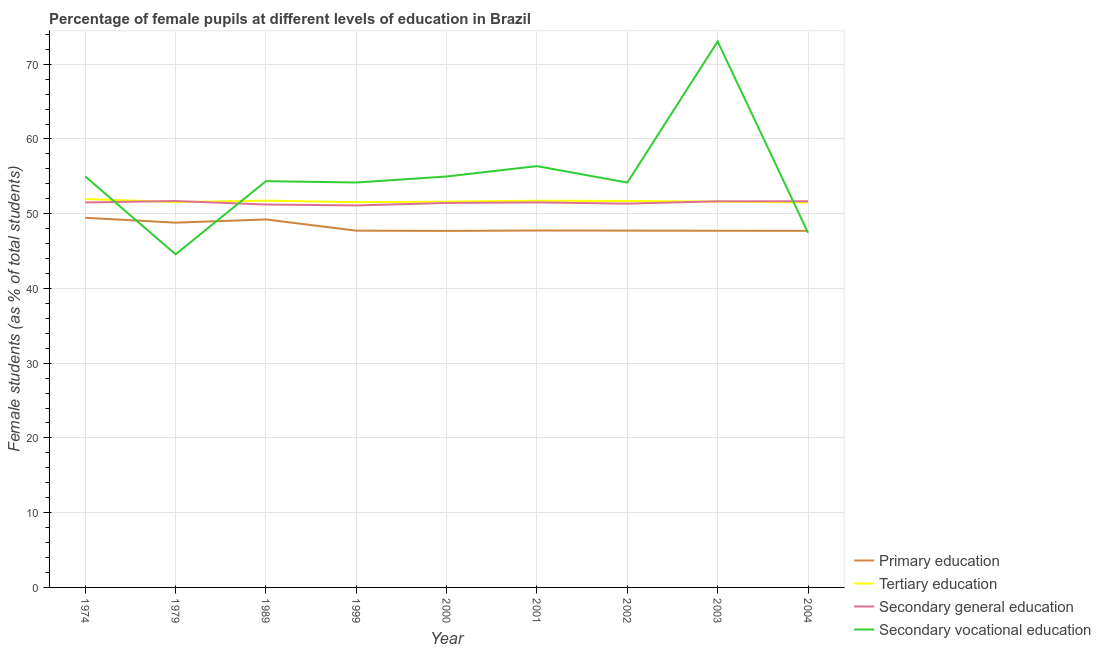How many different coloured lines are there?
Ensure brevity in your answer.  4. Does the line corresponding to percentage of female students in secondary education intersect with the line corresponding to percentage of female students in tertiary education?
Offer a terse response. Yes. What is the percentage of female students in secondary vocational education in 2001?
Provide a short and direct response. 56.37. Across all years, what is the maximum percentage of female students in secondary vocational education?
Keep it short and to the point. 73.04. Across all years, what is the minimum percentage of female students in secondary education?
Offer a terse response. 51.11. In which year was the percentage of female students in tertiary education maximum?
Offer a terse response. 1974. In which year was the percentage of female students in secondary vocational education minimum?
Keep it short and to the point. 1979. What is the total percentage of female students in secondary vocational education in the graph?
Offer a terse response. 494.09. What is the difference between the percentage of female students in secondary education in 1999 and that in 2001?
Your response must be concise. -0.4. What is the difference between the percentage of female students in secondary education in 2000 and the percentage of female students in primary education in 2003?
Ensure brevity in your answer.  3.72. What is the average percentage of female students in secondary vocational education per year?
Give a very brief answer. 54.9. In the year 1999, what is the difference between the percentage of female students in secondary education and percentage of female students in secondary vocational education?
Your response must be concise. -3.07. What is the ratio of the percentage of female students in tertiary education in 1979 to that in 2003?
Give a very brief answer. 1. What is the difference between the highest and the second highest percentage of female students in secondary education?
Keep it short and to the point. 0.03. What is the difference between the highest and the lowest percentage of female students in tertiary education?
Give a very brief answer. 0.47. In how many years, is the percentage of female students in secondary vocational education greater than the average percentage of female students in secondary vocational education taken over all years?
Offer a very short reply. 4. Is the sum of the percentage of female students in secondary vocational education in 1979 and 2001 greater than the maximum percentage of female students in primary education across all years?
Provide a succinct answer. Yes. Is it the case that in every year, the sum of the percentage of female students in secondary vocational education and percentage of female students in primary education is greater than the sum of percentage of female students in secondary education and percentage of female students in tertiary education?
Provide a short and direct response. No. Is the percentage of female students in secondary vocational education strictly greater than the percentage of female students in secondary education over the years?
Your answer should be compact. No. How many lines are there?
Offer a terse response. 4. Are the values on the major ticks of Y-axis written in scientific E-notation?
Offer a terse response. No. Does the graph contain any zero values?
Your answer should be very brief. No. Where does the legend appear in the graph?
Provide a succinct answer. Bottom right. How are the legend labels stacked?
Provide a short and direct response. Vertical. What is the title of the graph?
Provide a succinct answer. Percentage of female pupils at different levels of education in Brazil. Does "Third 20% of population" appear as one of the legend labels in the graph?
Your response must be concise. No. What is the label or title of the X-axis?
Offer a very short reply. Year. What is the label or title of the Y-axis?
Provide a short and direct response. Female students (as % of total students). What is the Female students (as % of total students) of Primary education in 1974?
Provide a succinct answer. 49.45. What is the Female students (as % of total students) in Tertiary education in 1974?
Keep it short and to the point. 51.97. What is the Female students (as % of total students) of Secondary general education in 1974?
Provide a succinct answer. 51.51. What is the Female students (as % of total students) in Secondary vocational education in 1974?
Keep it short and to the point. 54.98. What is the Female students (as % of total students) in Primary education in 1979?
Offer a very short reply. 48.8. What is the Female students (as % of total students) in Tertiary education in 1979?
Your response must be concise. 51.56. What is the Female students (as % of total students) in Secondary general education in 1979?
Provide a succinct answer. 51.7. What is the Female students (as % of total students) of Secondary vocational education in 1979?
Give a very brief answer. 44.57. What is the Female students (as % of total students) of Primary education in 1989?
Keep it short and to the point. 49.23. What is the Female students (as % of total students) of Tertiary education in 1989?
Give a very brief answer. 51.75. What is the Female students (as % of total students) of Secondary general education in 1989?
Give a very brief answer. 51.23. What is the Female students (as % of total students) of Secondary vocational education in 1989?
Offer a terse response. 54.36. What is the Female students (as % of total students) in Primary education in 1999?
Offer a very short reply. 47.73. What is the Female students (as % of total students) of Tertiary education in 1999?
Offer a very short reply. 51.54. What is the Female students (as % of total students) in Secondary general education in 1999?
Your response must be concise. 51.11. What is the Female students (as % of total students) in Secondary vocational education in 1999?
Give a very brief answer. 54.17. What is the Female students (as % of total students) of Primary education in 2000?
Provide a succinct answer. 47.7. What is the Female students (as % of total students) of Tertiary education in 2000?
Offer a terse response. 51.62. What is the Female students (as % of total students) in Secondary general education in 2000?
Offer a terse response. 51.44. What is the Female students (as % of total students) in Secondary vocational education in 2000?
Offer a very short reply. 54.98. What is the Female students (as % of total students) in Primary education in 2001?
Make the answer very short. 47.75. What is the Female students (as % of total students) in Tertiary education in 2001?
Your answer should be very brief. 51.74. What is the Female students (as % of total students) in Secondary general education in 2001?
Keep it short and to the point. 51.51. What is the Female students (as % of total students) in Secondary vocational education in 2001?
Provide a succinct answer. 56.37. What is the Female students (as % of total students) in Primary education in 2002?
Provide a short and direct response. 47.74. What is the Female students (as % of total students) in Tertiary education in 2002?
Your answer should be very brief. 51.71. What is the Female students (as % of total students) in Secondary general education in 2002?
Your response must be concise. 51.35. What is the Female students (as % of total students) in Secondary vocational education in 2002?
Your response must be concise. 54.16. What is the Female students (as % of total students) of Primary education in 2003?
Give a very brief answer. 47.72. What is the Female students (as % of total students) in Tertiary education in 2003?
Make the answer very short. 51.62. What is the Female students (as % of total students) in Secondary general education in 2003?
Your answer should be compact. 51.66. What is the Female students (as % of total students) of Secondary vocational education in 2003?
Provide a succinct answer. 73.04. What is the Female students (as % of total students) of Primary education in 2004?
Keep it short and to the point. 47.71. What is the Female students (as % of total students) of Tertiary education in 2004?
Give a very brief answer. 51.5. What is the Female students (as % of total students) in Secondary general education in 2004?
Ensure brevity in your answer.  51.66. What is the Female students (as % of total students) of Secondary vocational education in 2004?
Make the answer very short. 47.46. Across all years, what is the maximum Female students (as % of total students) of Primary education?
Provide a succinct answer. 49.45. Across all years, what is the maximum Female students (as % of total students) in Tertiary education?
Your answer should be compact. 51.97. Across all years, what is the maximum Female students (as % of total students) of Secondary general education?
Your response must be concise. 51.7. Across all years, what is the maximum Female students (as % of total students) in Secondary vocational education?
Provide a short and direct response. 73.04. Across all years, what is the minimum Female students (as % of total students) of Primary education?
Ensure brevity in your answer.  47.7. Across all years, what is the minimum Female students (as % of total students) in Tertiary education?
Offer a terse response. 51.5. Across all years, what is the minimum Female students (as % of total students) in Secondary general education?
Provide a succinct answer. 51.11. Across all years, what is the minimum Female students (as % of total students) in Secondary vocational education?
Keep it short and to the point. 44.57. What is the total Female students (as % of total students) of Primary education in the graph?
Ensure brevity in your answer.  433.83. What is the total Female students (as % of total students) in Tertiary education in the graph?
Offer a very short reply. 464.99. What is the total Female students (as % of total students) in Secondary general education in the graph?
Ensure brevity in your answer.  463.16. What is the total Female students (as % of total students) in Secondary vocational education in the graph?
Provide a succinct answer. 494.09. What is the difference between the Female students (as % of total students) in Primary education in 1974 and that in 1979?
Offer a terse response. 0.65. What is the difference between the Female students (as % of total students) of Tertiary education in 1974 and that in 1979?
Your response must be concise. 0.41. What is the difference between the Female students (as % of total students) of Secondary general education in 1974 and that in 1979?
Your response must be concise. -0.19. What is the difference between the Female students (as % of total students) of Secondary vocational education in 1974 and that in 1979?
Provide a succinct answer. 10.41. What is the difference between the Female students (as % of total students) in Primary education in 1974 and that in 1989?
Give a very brief answer. 0.22. What is the difference between the Female students (as % of total students) in Tertiary education in 1974 and that in 1989?
Provide a short and direct response. 0.22. What is the difference between the Female students (as % of total students) in Secondary general education in 1974 and that in 1989?
Your answer should be very brief. 0.28. What is the difference between the Female students (as % of total students) in Secondary vocational education in 1974 and that in 1989?
Give a very brief answer. 0.62. What is the difference between the Female students (as % of total students) in Primary education in 1974 and that in 1999?
Your answer should be compact. 1.72. What is the difference between the Female students (as % of total students) of Tertiary education in 1974 and that in 1999?
Offer a very short reply. 0.43. What is the difference between the Female students (as % of total students) in Secondary general education in 1974 and that in 1999?
Your response must be concise. 0.4. What is the difference between the Female students (as % of total students) in Secondary vocational education in 1974 and that in 1999?
Your answer should be very brief. 0.8. What is the difference between the Female students (as % of total students) of Primary education in 1974 and that in 2000?
Your answer should be compact. 1.75. What is the difference between the Female students (as % of total students) in Tertiary education in 1974 and that in 2000?
Make the answer very short. 0.34. What is the difference between the Female students (as % of total students) in Secondary general education in 1974 and that in 2000?
Ensure brevity in your answer.  0.07. What is the difference between the Female students (as % of total students) of Secondary vocational education in 1974 and that in 2000?
Your answer should be very brief. -0. What is the difference between the Female students (as % of total students) in Primary education in 1974 and that in 2001?
Provide a succinct answer. 1.7. What is the difference between the Female students (as % of total students) of Tertiary education in 1974 and that in 2001?
Ensure brevity in your answer.  0.23. What is the difference between the Female students (as % of total students) of Secondary general education in 1974 and that in 2001?
Offer a terse response. -0. What is the difference between the Female students (as % of total students) of Secondary vocational education in 1974 and that in 2001?
Ensure brevity in your answer.  -1.39. What is the difference between the Female students (as % of total students) of Primary education in 1974 and that in 2002?
Provide a succinct answer. 1.71. What is the difference between the Female students (as % of total students) of Tertiary education in 1974 and that in 2002?
Ensure brevity in your answer.  0.26. What is the difference between the Female students (as % of total students) in Secondary general education in 1974 and that in 2002?
Provide a succinct answer. 0.16. What is the difference between the Female students (as % of total students) in Secondary vocational education in 1974 and that in 2002?
Provide a succinct answer. 0.81. What is the difference between the Female students (as % of total students) in Primary education in 1974 and that in 2003?
Your response must be concise. 1.73. What is the difference between the Female students (as % of total students) of Tertiary education in 1974 and that in 2003?
Offer a terse response. 0.35. What is the difference between the Female students (as % of total students) of Secondary general education in 1974 and that in 2003?
Your answer should be very brief. -0.15. What is the difference between the Female students (as % of total students) in Secondary vocational education in 1974 and that in 2003?
Provide a succinct answer. -18.07. What is the difference between the Female students (as % of total students) of Primary education in 1974 and that in 2004?
Offer a very short reply. 1.75. What is the difference between the Female students (as % of total students) in Tertiary education in 1974 and that in 2004?
Your response must be concise. 0.47. What is the difference between the Female students (as % of total students) in Secondary general education in 1974 and that in 2004?
Make the answer very short. -0.15. What is the difference between the Female students (as % of total students) of Secondary vocational education in 1974 and that in 2004?
Make the answer very short. 7.52. What is the difference between the Female students (as % of total students) in Primary education in 1979 and that in 1989?
Give a very brief answer. -0.43. What is the difference between the Female students (as % of total students) in Tertiary education in 1979 and that in 1989?
Offer a terse response. -0.19. What is the difference between the Female students (as % of total students) in Secondary general education in 1979 and that in 1989?
Your response must be concise. 0.47. What is the difference between the Female students (as % of total students) of Secondary vocational education in 1979 and that in 1989?
Provide a short and direct response. -9.79. What is the difference between the Female students (as % of total students) of Primary education in 1979 and that in 1999?
Provide a succinct answer. 1.07. What is the difference between the Female students (as % of total students) of Tertiary education in 1979 and that in 1999?
Offer a very short reply. 0.02. What is the difference between the Female students (as % of total students) in Secondary general education in 1979 and that in 1999?
Provide a short and direct response. 0.59. What is the difference between the Female students (as % of total students) of Secondary vocational education in 1979 and that in 1999?
Your answer should be very brief. -9.61. What is the difference between the Female students (as % of total students) in Primary education in 1979 and that in 2000?
Offer a terse response. 1.1. What is the difference between the Female students (as % of total students) in Tertiary education in 1979 and that in 2000?
Provide a succinct answer. -0.06. What is the difference between the Female students (as % of total students) of Secondary general education in 1979 and that in 2000?
Offer a very short reply. 0.26. What is the difference between the Female students (as % of total students) in Secondary vocational education in 1979 and that in 2000?
Your response must be concise. -10.41. What is the difference between the Female students (as % of total students) in Primary education in 1979 and that in 2001?
Your answer should be compact. 1.05. What is the difference between the Female students (as % of total students) in Tertiary education in 1979 and that in 2001?
Offer a very short reply. -0.18. What is the difference between the Female students (as % of total students) of Secondary general education in 1979 and that in 2001?
Offer a terse response. 0.18. What is the difference between the Female students (as % of total students) in Secondary vocational education in 1979 and that in 2001?
Your response must be concise. -11.8. What is the difference between the Female students (as % of total students) in Primary education in 1979 and that in 2002?
Provide a short and direct response. 1.06. What is the difference between the Female students (as % of total students) of Tertiary education in 1979 and that in 2002?
Your response must be concise. -0.15. What is the difference between the Female students (as % of total students) in Secondary general education in 1979 and that in 2002?
Your answer should be compact. 0.35. What is the difference between the Female students (as % of total students) of Secondary vocational education in 1979 and that in 2002?
Your answer should be very brief. -9.6. What is the difference between the Female students (as % of total students) in Primary education in 1979 and that in 2003?
Give a very brief answer. 1.08. What is the difference between the Female students (as % of total students) in Tertiary education in 1979 and that in 2003?
Make the answer very short. -0.06. What is the difference between the Female students (as % of total students) in Secondary general education in 1979 and that in 2003?
Give a very brief answer. 0.04. What is the difference between the Female students (as % of total students) of Secondary vocational education in 1979 and that in 2003?
Give a very brief answer. -28.48. What is the difference between the Female students (as % of total students) in Primary education in 1979 and that in 2004?
Keep it short and to the point. 1.1. What is the difference between the Female students (as % of total students) in Tertiary education in 1979 and that in 2004?
Your answer should be compact. 0.06. What is the difference between the Female students (as % of total students) in Secondary general education in 1979 and that in 2004?
Provide a short and direct response. 0.03. What is the difference between the Female students (as % of total students) in Secondary vocational education in 1979 and that in 2004?
Provide a short and direct response. -2.89. What is the difference between the Female students (as % of total students) in Primary education in 1989 and that in 1999?
Offer a very short reply. 1.5. What is the difference between the Female students (as % of total students) of Tertiary education in 1989 and that in 1999?
Give a very brief answer. 0.21. What is the difference between the Female students (as % of total students) in Secondary general education in 1989 and that in 1999?
Keep it short and to the point. 0.12. What is the difference between the Female students (as % of total students) in Secondary vocational education in 1989 and that in 1999?
Keep it short and to the point. 0.19. What is the difference between the Female students (as % of total students) of Primary education in 1989 and that in 2000?
Provide a short and direct response. 1.53. What is the difference between the Female students (as % of total students) in Tertiary education in 1989 and that in 2000?
Your answer should be compact. 0.12. What is the difference between the Female students (as % of total students) in Secondary general education in 1989 and that in 2000?
Your response must be concise. -0.21. What is the difference between the Female students (as % of total students) of Secondary vocational education in 1989 and that in 2000?
Ensure brevity in your answer.  -0.62. What is the difference between the Female students (as % of total students) in Primary education in 1989 and that in 2001?
Your answer should be compact. 1.48. What is the difference between the Female students (as % of total students) in Tertiary education in 1989 and that in 2001?
Provide a short and direct response. 0.01. What is the difference between the Female students (as % of total students) in Secondary general education in 1989 and that in 2001?
Provide a succinct answer. -0.28. What is the difference between the Female students (as % of total students) in Secondary vocational education in 1989 and that in 2001?
Make the answer very short. -2.01. What is the difference between the Female students (as % of total students) in Primary education in 1989 and that in 2002?
Keep it short and to the point. 1.49. What is the difference between the Female students (as % of total students) in Tertiary education in 1989 and that in 2002?
Give a very brief answer. 0.04. What is the difference between the Female students (as % of total students) in Secondary general education in 1989 and that in 2002?
Make the answer very short. -0.12. What is the difference between the Female students (as % of total students) of Secondary vocational education in 1989 and that in 2002?
Make the answer very short. 0.19. What is the difference between the Female students (as % of total students) in Primary education in 1989 and that in 2003?
Ensure brevity in your answer.  1.51. What is the difference between the Female students (as % of total students) in Tertiary education in 1989 and that in 2003?
Provide a succinct answer. 0.13. What is the difference between the Female students (as % of total students) of Secondary general education in 1989 and that in 2003?
Your answer should be very brief. -0.43. What is the difference between the Female students (as % of total students) of Secondary vocational education in 1989 and that in 2003?
Provide a short and direct response. -18.69. What is the difference between the Female students (as % of total students) of Primary education in 1989 and that in 2004?
Provide a short and direct response. 1.52. What is the difference between the Female students (as % of total students) of Tertiary education in 1989 and that in 2004?
Your answer should be very brief. 0.25. What is the difference between the Female students (as % of total students) of Secondary general education in 1989 and that in 2004?
Provide a succinct answer. -0.43. What is the difference between the Female students (as % of total students) in Secondary vocational education in 1989 and that in 2004?
Provide a succinct answer. 6.9. What is the difference between the Female students (as % of total students) of Primary education in 1999 and that in 2000?
Provide a short and direct response. 0.03. What is the difference between the Female students (as % of total students) of Tertiary education in 1999 and that in 2000?
Offer a very short reply. -0.09. What is the difference between the Female students (as % of total students) of Secondary general education in 1999 and that in 2000?
Provide a succinct answer. -0.33. What is the difference between the Female students (as % of total students) in Secondary vocational education in 1999 and that in 2000?
Make the answer very short. -0.81. What is the difference between the Female students (as % of total students) in Primary education in 1999 and that in 2001?
Offer a very short reply. -0.02. What is the difference between the Female students (as % of total students) in Tertiary education in 1999 and that in 2001?
Give a very brief answer. -0.2. What is the difference between the Female students (as % of total students) in Secondary general education in 1999 and that in 2001?
Make the answer very short. -0.4. What is the difference between the Female students (as % of total students) in Secondary vocational education in 1999 and that in 2001?
Give a very brief answer. -2.2. What is the difference between the Female students (as % of total students) of Primary education in 1999 and that in 2002?
Make the answer very short. -0.01. What is the difference between the Female students (as % of total students) in Tertiary education in 1999 and that in 2002?
Give a very brief answer. -0.17. What is the difference between the Female students (as % of total students) of Secondary general education in 1999 and that in 2002?
Give a very brief answer. -0.24. What is the difference between the Female students (as % of total students) of Secondary vocational education in 1999 and that in 2002?
Provide a short and direct response. 0.01. What is the difference between the Female students (as % of total students) of Primary education in 1999 and that in 2003?
Your answer should be very brief. 0.01. What is the difference between the Female students (as % of total students) in Tertiary education in 1999 and that in 2003?
Provide a succinct answer. -0.08. What is the difference between the Female students (as % of total students) in Secondary general education in 1999 and that in 2003?
Offer a terse response. -0.55. What is the difference between the Female students (as % of total students) in Secondary vocational education in 1999 and that in 2003?
Ensure brevity in your answer.  -18.87. What is the difference between the Female students (as % of total students) of Primary education in 1999 and that in 2004?
Ensure brevity in your answer.  0.02. What is the difference between the Female students (as % of total students) of Tertiary education in 1999 and that in 2004?
Ensure brevity in your answer.  0.04. What is the difference between the Female students (as % of total students) in Secondary general education in 1999 and that in 2004?
Make the answer very short. -0.56. What is the difference between the Female students (as % of total students) in Secondary vocational education in 1999 and that in 2004?
Give a very brief answer. 6.71. What is the difference between the Female students (as % of total students) of Primary education in 2000 and that in 2001?
Give a very brief answer. -0.05. What is the difference between the Female students (as % of total students) of Tertiary education in 2000 and that in 2001?
Provide a succinct answer. -0.11. What is the difference between the Female students (as % of total students) of Secondary general education in 2000 and that in 2001?
Keep it short and to the point. -0.07. What is the difference between the Female students (as % of total students) of Secondary vocational education in 2000 and that in 2001?
Your answer should be compact. -1.39. What is the difference between the Female students (as % of total students) of Primary education in 2000 and that in 2002?
Give a very brief answer. -0.04. What is the difference between the Female students (as % of total students) in Tertiary education in 2000 and that in 2002?
Your answer should be very brief. -0.08. What is the difference between the Female students (as % of total students) in Secondary general education in 2000 and that in 2002?
Offer a very short reply. 0.09. What is the difference between the Female students (as % of total students) in Secondary vocational education in 2000 and that in 2002?
Your answer should be compact. 0.82. What is the difference between the Female students (as % of total students) in Primary education in 2000 and that in 2003?
Provide a short and direct response. -0.02. What is the difference between the Female students (as % of total students) of Tertiary education in 2000 and that in 2003?
Offer a terse response. 0. What is the difference between the Female students (as % of total students) in Secondary general education in 2000 and that in 2003?
Make the answer very short. -0.22. What is the difference between the Female students (as % of total students) in Secondary vocational education in 2000 and that in 2003?
Ensure brevity in your answer.  -18.07. What is the difference between the Female students (as % of total students) in Primary education in 2000 and that in 2004?
Keep it short and to the point. -0.01. What is the difference between the Female students (as % of total students) of Tertiary education in 2000 and that in 2004?
Give a very brief answer. 0.12. What is the difference between the Female students (as % of total students) in Secondary general education in 2000 and that in 2004?
Make the answer very short. -0.22. What is the difference between the Female students (as % of total students) of Secondary vocational education in 2000 and that in 2004?
Provide a succinct answer. 7.52. What is the difference between the Female students (as % of total students) of Primary education in 2001 and that in 2002?
Offer a very short reply. 0.02. What is the difference between the Female students (as % of total students) of Tertiary education in 2001 and that in 2002?
Offer a very short reply. 0.03. What is the difference between the Female students (as % of total students) in Secondary general education in 2001 and that in 2002?
Provide a succinct answer. 0.16. What is the difference between the Female students (as % of total students) of Secondary vocational education in 2001 and that in 2002?
Offer a very short reply. 2.2. What is the difference between the Female students (as % of total students) of Primary education in 2001 and that in 2003?
Your answer should be very brief. 0.03. What is the difference between the Female students (as % of total students) in Tertiary education in 2001 and that in 2003?
Your response must be concise. 0.12. What is the difference between the Female students (as % of total students) of Secondary general education in 2001 and that in 2003?
Provide a succinct answer. -0.15. What is the difference between the Female students (as % of total students) of Secondary vocational education in 2001 and that in 2003?
Provide a short and direct response. -16.68. What is the difference between the Female students (as % of total students) of Primary education in 2001 and that in 2004?
Your response must be concise. 0.05. What is the difference between the Female students (as % of total students) in Tertiary education in 2001 and that in 2004?
Give a very brief answer. 0.24. What is the difference between the Female students (as % of total students) in Secondary general education in 2001 and that in 2004?
Offer a very short reply. -0.15. What is the difference between the Female students (as % of total students) of Secondary vocational education in 2001 and that in 2004?
Your response must be concise. 8.91. What is the difference between the Female students (as % of total students) of Primary education in 2002 and that in 2003?
Make the answer very short. 0.02. What is the difference between the Female students (as % of total students) in Tertiary education in 2002 and that in 2003?
Make the answer very short. 0.09. What is the difference between the Female students (as % of total students) in Secondary general education in 2002 and that in 2003?
Your response must be concise. -0.31. What is the difference between the Female students (as % of total students) of Secondary vocational education in 2002 and that in 2003?
Ensure brevity in your answer.  -18.88. What is the difference between the Female students (as % of total students) in Primary education in 2002 and that in 2004?
Ensure brevity in your answer.  0.03. What is the difference between the Female students (as % of total students) of Tertiary education in 2002 and that in 2004?
Your answer should be compact. 0.21. What is the difference between the Female students (as % of total students) in Secondary general education in 2002 and that in 2004?
Provide a succinct answer. -0.32. What is the difference between the Female students (as % of total students) of Secondary vocational education in 2002 and that in 2004?
Make the answer very short. 6.7. What is the difference between the Female students (as % of total students) of Primary education in 2003 and that in 2004?
Your answer should be very brief. 0.01. What is the difference between the Female students (as % of total students) in Tertiary education in 2003 and that in 2004?
Provide a succinct answer. 0.12. What is the difference between the Female students (as % of total students) in Secondary general education in 2003 and that in 2004?
Offer a very short reply. -0.01. What is the difference between the Female students (as % of total students) of Secondary vocational education in 2003 and that in 2004?
Keep it short and to the point. 25.58. What is the difference between the Female students (as % of total students) in Primary education in 1974 and the Female students (as % of total students) in Tertiary education in 1979?
Provide a short and direct response. -2.11. What is the difference between the Female students (as % of total students) of Primary education in 1974 and the Female students (as % of total students) of Secondary general education in 1979?
Ensure brevity in your answer.  -2.24. What is the difference between the Female students (as % of total students) in Primary education in 1974 and the Female students (as % of total students) in Secondary vocational education in 1979?
Offer a terse response. 4.88. What is the difference between the Female students (as % of total students) of Tertiary education in 1974 and the Female students (as % of total students) of Secondary general education in 1979?
Your response must be concise. 0.27. What is the difference between the Female students (as % of total students) in Tertiary education in 1974 and the Female students (as % of total students) in Secondary vocational education in 1979?
Offer a very short reply. 7.4. What is the difference between the Female students (as % of total students) in Secondary general education in 1974 and the Female students (as % of total students) in Secondary vocational education in 1979?
Provide a succinct answer. 6.94. What is the difference between the Female students (as % of total students) in Primary education in 1974 and the Female students (as % of total students) in Tertiary education in 1989?
Provide a succinct answer. -2.3. What is the difference between the Female students (as % of total students) in Primary education in 1974 and the Female students (as % of total students) in Secondary general education in 1989?
Ensure brevity in your answer.  -1.78. What is the difference between the Female students (as % of total students) of Primary education in 1974 and the Female students (as % of total students) of Secondary vocational education in 1989?
Your answer should be very brief. -4.91. What is the difference between the Female students (as % of total students) of Tertiary education in 1974 and the Female students (as % of total students) of Secondary general education in 1989?
Offer a terse response. 0.73. What is the difference between the Female students (as % of total students) in Tertiary education in 1974 and the Female students (as % of total students) in Secondary vocational education in 1989?
Ensure brevity in your answer.  -2.39. What is the difference between the Female students (as % of total students) of Secondary general education in 1974 and the Female students (as % of total students) of Secondary vocational education in 1989?
Your answer should be very brief. -2.85. What is the difference between the Female students (as % of total students) in Primary education in 1974 and the Female students (as % of total students) in Tertiary education in 1999?
Your answer should be compact. -2.09. What is the difference between the Female students (as % of total students) in Primary education in 1974 and the Female students (as % of total students) in Secondary general education in 1999?
Give a very brief answer. -1.66. What is the difference between the Female students (as % of total students) in Primary education in 1974 and the Female students (as % of total students) in Secondary vocational education in 1999?
Ensure brevity in your answer.  -4.72. What is the difference between the Female students (as % of total students) in Tertiary education in 1974 and the Female students (as % of total students) in Secondary general education in 1999?
Provide a short and direct response. 0.86. What is the difference between the Female students (as % of total students) in Tertiary education in 1974 and the Female students (as % of total students) in Secondary vocational education in 1999?
Offer a terse response. -2.21. What is the difference between the Female students (as % of total students) in Secondary general education in 1974 and the Female students (as % of total students) in Secondary vocational education in 1999?
Make the answer very short. -2.66. What is the difference between the Female students (as % of total students) in Primary education in 1974 and the Female students (as % of total students) in Tertiary education in 2000?
Ensure brevity in your answer.  -2.17. What is the difference between the Female students (as % of total students) in Primary education in 1974 and the Female students (as % of total students) in Secondary general education in 2000?
Ensure brevity in your answer.  -1.99. What is the difference between the Female students (as % of total students) of Primary education in 1974 and the Female students (as % of total students) of Secondary vocational education in 2000?
Your response must be concise. -5.53. What is the difference between the Female students (as % of total students) of Tertiary education in 1974 and the Female students (as % of total students) of Secondary general education in 2000?
Your answer should be very brief. 0.53. What is the difference between the Female students (as % of total students) in Tertiary education in 1974 and the Female students (as % of total students) in Secondary vocational education in 2000?
Make the answer very short. -3.01. What is the difference between the Female students (as % of total students) of Secondary general education in 1974 and the Female students (as % of total students) of Secondary vocational education in 2000?
Make the answer very short. -3.47. What is the difference between the Female students (as % of total students) in Primary education in 1974 and the Female students (as % of total students) in Tertiary education in 2001?
Your response must be concise. -2.28. What is the difference between the Female students (as % of total students) in Primary education in 1974 and the Female students (as % of total students) in Secondary general education in 2001?
Keep it short and to the point. -2.06. What is the difference between the Female students (as % of total students) of Primary education in 1974 and the Female students (as % of total students) of Secondary vocational education in 2001?
Your answer should be compact. -6.92. What is the difference between the Female students (as % of total students) of Tertiary education in 1974 and the Female students (as % of total students) of Secondary general education in 2001?
Your response must be concise. 0.45. What is the difference between the Female students (as % of total students) in Tertiary education in 1974 and the Female students (as % of total students) in Secondary vocational education in 2001?
Provide a succinct answer. -4.4. What is the difference between the Female students (as % of total students) of Secondary general education in 1974 and the Female students (as % of total students) of Secondary vocational education in 2001?
Provide a short and direct response. -4.86. What is the difference between the Female students (as % of total students) in Primary education in 1974 and the Female students (as % of total students) in Tertiary education in 2002?
Your answer should be compact. -2.25. What is the difference between the Female students (as % of total students) of Primary education in 1974 and the Female students (as % of total students) of Secondary general education in 2002?
Offer a very short reply. -1.9. What is the difference between the Female students (as % of total students) of Primary education in 1974 and the Female students (as % of total students) of Secondary vocational education in 2002?
Your answer should be very brief. -4.71. What is the difference between the Female students (as % of total students) of Tertiary education in 1974 and the Female students (as % of total students) of Secondary general education in 2002?
Keep it short and to the point. 0.62. What is the difference between the Female students (as % of total students) of Tertiary education in 1974 and the Female students (as % of total students) of Secondary vocational education in 2002?
Ensure brevity in your answer.  -2.2. What is the difference between the Female students (as % of total students) of Secondary general education in 1974 and the Female students (as % of total students) of Secondary vocational education in 2002?
Give a very brief answer. -2.65. What is the difference between the Female students (as % of total students) of Primary education in 1974 and the Female students (as % of total students) of Tertiary education in 2003?
Make the answer very short. -2.17. What is the difference between the Female students (as % of total students) of Primary education in 1974 and the Female students (as % of total students) of Secondary general education in 2003?
Your response must be concise. -2.21. What is the difference between the Female students (as % of total students) in Primary education in 1974 and the Female students (as % of total students) in Secondary vocational education in 2003?
Your answer should be compact. -23.59. What is the difference between the Female students (as % of total students) of Tertiary education in 1974 and the Female students (as % of total students) of Secondary general education in 2003?
Make the answer very short. 0.31. What is the difference between the Female students (as % of total students) of Tertiary education in 1974 and the Female students (as % of total students) of Secondary vocational education in 2003?
Your answer should be very brief. -21.08. What is the difference between the Female students (as % of total students) in Secondary general education in 1974 and the Female students (as % of total students) in Secondary vocational education in 2003?
Provide a succinct answer. -21.53. What is the difference between the Female students (as % of total students) in Primary education in 1974 and the Female students (as % of total students) in Tertiary education in 2004?
Your answer should be very brief. -2.05. What is the difference between the Female students (as % of total students) in Primary education in 1974 and the Female students (as % of total students) in Secondary general education in 2004?
Provide a succinct answer. -2.21. What is the difference between the Female students (as % of total students) of Primary education in 1974 and the Female students (as % of total students) of Secondary vocational education in 2004?
Offer a terse response. 1.99. What is the difference between the Female students (as % of total students) in Tertiary education in 1974 and the Female students (as % of total students) in Secondary general education in 2004?
Keep it short and to the point. 0.3. What is the difference between the Female students (as % of total students) in Tertiary education in 1974 and the Female students (as % of total students) in Secondary vocational education in 2004?
Make the answer very short. 4.5. What is the difference between the Female students (as % of total students) of Secondary general education in 1974 and the Female students (as % of total students) of Secondary vocational education in 2004?
Offer a very short reply. 4.05. What is the difference between the Female students (as % of total students) in Primary education in 1979 and the Female students (as % of total students) in Tertiary education in 1989?
Provide a short and direct response. -2.94. What is the difference between the Female students (as % of total students) in Primary education in 1979 and the Female students (as % of total students) in Secondary general education in 1989?
Your answer should be very brief. -2.43. What is the difference between the Female students (as % of total students) in Primary education in 1979 and the Female students (as % of total students) in Secondary vocational education in 1989?
Provide a short and direct response. -5.56. What is the difference between the Female students (as % of total students) in Tertiary education in 1979 and the Female students (as % of total students) in Secondary general education in 1989?
Make the answer very short. 0.33. What is the difference between the Female students (as % of total students) in Tertiary education in 1979 and the Female students (as % of total students) in Secondary vocational education in 1989?
Your answer should be very brief. -2.8. What is the difference between the Female students (as % of total students) in Secondary general education in 1979 and the Female students (as % of total students) in Secondary vocational education in 1989?
Offer a terse response. -2.66. What is the difference between the Female students (as % of total students) in Primary education in 1979 and the Female students (as % of total students) in Tertiary education in 1999?
Offer a very short reply. -2.74. What is the difference between the Female students (as % of total students) in Primary education in 1979 and the Female students (as % of total students) in Secondary general education in 1999?
Keep it short and to the point. -2.3. What is the difference between the Female students (as % of total students) in Primary education in 1979 and the Female students (as % of total students) in Secondary vocational education in 1999?
Keep it short and to the point. -5.37. What is the difference between the Female students (as % of total students) of Tertiary education in 1979 and the Female students (as % of total students) of Secondary general education in 1999?
Your answer should be compact. 0.45. What is the difference between the Female students (as % of total students) of Tertiary education in 1979 and the Female students (as % of total students) of Secondary vocational education in 1999?
Keep it short and to the point. -2.61. What is the difference between the Female students (as % of total students) of Secondary general education in 1979 and the Female students (as % of total students) of Secondary vocational education in 1999?
Offer a terse response. -2.48. What is the difference between the Female students (as % of total students) in Primary education in 1979 and the Female students (as % of total students) in Tertiary education in 2000?
Ensure brevity in your answer.  -2.82. What is the difference between the Female students (as % of total students) in Primary education in 1979 and the Female students (as % of total students) in Secondary general education in 2000?
Provide a succinct answer. -2.64. What is the difference between the Female students (as % of total students) of Primary education in 1979 and the Female students (as % of total students) of Secondary vocational education in 2000?
Your answer should be very brief. -6.18. What is the difference between the Female students (as % of total students) in Tertiary education in 1979 and the Female students (as % of total students) in Secondary general education in 2000?
Ensure brevity in your answer.  0.12. What is the difference between the Female students (as % of total students) in Tertiary education in 1979 and the Female students (as % of total students) in Secondary vocational education in 2000?
Offer a very short reply. -3.42. What is the difference between the Female students (as % of total students) of Secondary general education in 1979 and the Female students (as % of total students) of Secondary vocational education in 2000?
Offer a terse response. -3.28. What is the difference between the Female students (as % of total students) of Primary education in 1979 and the Female students (as % of total students) of Tertiary education in 2001?
Make the answer very short. -2.93. What is the difference between the Female students (as % of total students) in Primary education in 1979 and the Female students (as % of total students) in Secondary general education in 2001?
Your response must be concise. -2.71. What is the difference between the Female students (as % of total students) in Primary education in 1979 and the Female students (as % of total students) in Secondary vocational education in 2001?
Offer a terse response. -7.57. What is the difference between the Female students (as % of total students) of Tertiary education in 1979 and the Female students (as % of total students) of Secondary general education in 2001?
Your response must be concise. 0.05. What is the difference between the Female students (as % of total students) in Tertiary education in 1979 and the Female students (as % of total students) in Secondary vocational education in 2001?
Give a very brief answer. -4.81. What is the difference between the Female students (as % of total students) of Secondary general education in 1979 and the Female students (as % of total students) of Secondary vocational education in 2001?
Keep it short and to the point. -4.67. What is the difference between the Female students (as % of total students) of Primary education in 1979 and the Female students (as % of total students) of Tertiary education in 2002?
Your answer should be very brief. -2.9. What is the difference between the Female students (as % of total students) in Primary education in 1979 and the Female students (as % of total students) in Secondary general education in 2002?
Give a very brief answer. -2.55. What is the difference between the Female students (as % of total students) in Primary education in 1979 and the Female students (as % of total students) in Secondary vocational education in 2002?
Your answer should be very brief. -5.36. What is the difference between the Female students (as % of total students) in Tertiary education in 1979 and the Female students (as % of total students) in Secondary general education in 2002?
Keep it short and to the point. 0.21. What is the difference between the Female students (as % of total students) in Tertiary education in 1979 and the Female students (as % of total students) in Secondary vocational education in 2002?
Offer a terse response. -2.6. What is the difference between the Female students (as % of total students) of Secondary general education in 1979 and the Female students (as % of total students) of Secondary vocational education in 2002?
Keep it short and to the point. -2.47. What is the difference between the Female students (as % of total students) of Primary education in 1979 and the Female students (as % of total students) of Tertiary education in 2003?
Make the answer very short. -2.82. What is the difference between the Female students (as % of total students) in Primary education in 1979 and the Female students (as % of total students) in Secondary general education in 2003?
Keep it short and to the point. -2.85. What is the difference between the Female students (as % of total students) in Primary education in 1979 and the Female students (as % of total students) in Secondary vocational education in 2003?
Offer a very short reply. -24.24. What is the difference between the Female students (as % of total students) in Tertiary education in 1979 and the Female students (as % of total students) in Secondary general education in 2003?
Ensure brevity in your answer.  -0.1. What is the difference between the Female students (as % of total students) in Tertiary education in 1979 and the Female students (as % of total students) in Secondary vocational education in 2003?
Ensure brevity in your answer.  -21.49. What is the difference between the Female students (as % of total students) in Secondary general education in 1979 and the Female students (as % of total students) in Secondary vocational education in 2003?
Your response must be concise. -21.35. What is the difference between the Female students (as % of total students) in Primary education in 1979 and the Female students (as % of total students) in Tertiary education in 2004?
Ensure brevity in your answer.  -2.7. What is the difference between the Female students (as % of total students) of Primary education in 1979 and the Female students (as % of total students) of Secondary general education in 2004?
Offer a terse response. -2.86. What is the difference between the Female students (as % of total students) of Primary education in 1979 and the Female students (as % of total students) of Secondary vocational education in 2004?
Your answer should be compact. 1.34. What is the difference between the Female students (as % of total students) of Tertiary education in 1979 and the Female students (as % of total students) of Secondary general education in 2004?
Offer a very short reply. -0.11. What is the difference between the Female students (as % of total students) of Tertiary education in 1979 and the Female students (as % of total students) of Secondary vocational education in 2004?
Ensure brevity in your answer.  4.1. What is the difference between the Female students (as % of total students) in Secondary general education in 1979 and the Female students (as % of total students) in Secondary vocational education in 2004?
Ensure brevity in your answer.  4.24. What is the difference between the Female students (as % of total students) in Primary education in 1989 and the Female students (as % of total students) in Tertiary education in 1999?
Your answer should be compact. -2.31. What is the difference between the Female students (as % of total students) of Primary education in 1989 and the Female students (as % of total students) of Secondary general education in 1999?
Provide a succinct answer. -1.88. What is the difference between the Female students (as % of total students) in Primary education in 1989 and the Female students (as % of total students) in Secondary vocational education in 1999?
Your response must be concise. -4.94. What is the difference between the Female students (as % of total students) in Tertiary education in 1989 and the Female students (as % of total students) in Secondary general education in 1999?
Your answer should be very brief. 0.64. What is the difference between the Female students (as % of total students) in Tertiary education in 1989 and the Female students (as % of total students) in Secondary vocational education in 1999?
Provide a succinct answer. -2.42. What is the difference between the Female students (as % of total students) of Secondary general education in 1989 and the Female students (as % of total students) of Secondary vocational education in 1999?
Ensure brevity in your answer.  -2.94. What is the difference between the Female students (as % of total students) in Primary education in 1989 and the Female students (as % of total students) in Tertiary education in 2000?
Offer a very short reply. -2.39. What is the difference between the Female students (as % of total students) of Primary education in 1989 and the Female students (as % of total students) of Secondary general education in 2000?
Your answer should be very brief. -2.21. What is the difference between the Female students (as % of total students) in Primary education in 1989 and the Female students (as % of total students) in Secondary vocational education in 2000?
Your response must be concise. -5.75. What is the difference between the Female students (as % of total students) in Tertiary education in 1989 and the Female students (as % of total students) in Secondary general education in 2000?
Give a very brief answer. 0.31. What is the difference between the Female students (as % of total students) in Tertiary education in 1989 and the Female students (as % of total students) in Secondary vocational education in 2000?
Provide a short and direct response. -3.23. What is the difference between the Female students (as % of total students) in Secondary general education in 1989 and the Female students (as % of total students) in Secondary vocational education in 2000?
Offer a very short reply. -3.75. What is the difference between the Female students (as % of total students) in Primary education in 1989 and the Female students (as % of total students) in Tertiary education in 2001?
Provide a succinct answer. -2.51. What is the difference between the Female students (as % of total students) in Primary education in 1989 and the Female students (as % of total students) in Secondary general education in 2001?
Offer a terse response. -2.28. What is the difference between the Female students (as % of total students) of Primary education in 1989 and the Female students (as % of total students) of Secondary vocational education in 2001?
Ensure brevity in your answer.  -7.14. What is the difference between the Female students (as % of total students) in Tertiary education in 1989 and the Female students (as % of total students) in Secondary general education in 2001?
Offer a terse response. 0.24. What is the difference between the Female students (as % of total students) of Tertiary education in 1989 and the Female students (as % of total students) of Secondary vocational education in 2001?
Keep it short and to the point. -4.62. What is the difference between the Female students (as % of total students) of Secondary general education in 1989 and the Female students (as % of total students) of Secondary vocational education in 2001?
Your answer should be very brief. -5.14. What is the difference between the Female students (as % of total students) in Primary education in 1989 and the Female students (as % of total students) in Tertiary education in 2002?
Offer a very short reply. -2.48. What is the difference between the Female students (as % of total students) in Primary education in 1989 and the Female students (as % of total students) in Secondary general education in 2002?
Provide a short and direct response. -2.12. What is the difference between the Female students (as % of total students) of Primary education in 1989 and the Female students (as % of total students) of Secondary vocational education in 2002?
Make the answer very short. -4.93. What is the difference between the Female students (as % of total students) of Tertiary education in 1989 and the Female students (as % of total students) of Secondary general education in 2002?
Provide a succinct answer. 0.4. What is the difference between the Female students (as % of total students) of Tertiary education in 1989 and the Female students (as % of total students) of Secondary vocational education in 2002?
Your response must be concise. -2.42. What is the difference between the Female students (as % of total students) in Secondary general education in 1989 and the Female students (as % of total students) in Secondary vocational education in 2002?
Ensure brevity in your answer.  -2.93. What is the difference between the Female students (as % of total students) in Primary education in 1989 and the Female students (as % of total students) in Tertiary education in 2003?
Make the answer very short. -2.39. What is the difference between the Female students (as % of total students) of Primary education in 1989 and the Female students (as % of total students) of Secondary general education in 2003?
Provide a succinct answer. -2.43. What is the difference between the Female students (as % of total students) of Primary education in 1989 and the Female students (as % of total students) of Secondary vocational education in 2003?
Your answer should be compact. -23.81. What is the difference between the Female students (as % of total students) of Tertiary education in 1989 and the Female students (as % of total students) of Secondary general education in 2003?
Offer a very short reply. 0.09. What is the difference between the Female students (as % of total students) of Tertiary education in 1989 and the Female students (as % of total students) of Secondary vocational education in 2003?
Your answer should be compact. -21.3. What is the difference between the Female students (as % of total students) in Secondary general education in 1989 and the Female students (as % of total students) in Secondary vocational education in 2003?
Ensure brevity in your answer.  -21.81. What is the difference between the Female students (as % of total students) in Primary education in 1989 and the Female students (as % of total students) in Tertiary education in 2004?
Ensure brevity in your answer.  -2.27. What is the difference between the Female students (as % of total students) of Primary education in 1989 and the Female students (as % of total students) of Secondary general education in 2004?
Provide a succinct answer. -2.43. What is the difference between the Female students (as % of total students) of Primary education in 1989 and the Female students (as % of total students) of Secondary vocational education in 2004?
Provide a short and direct response. 1.77. What is the difference between the Female students (as % of total students) of Tertiary education in 1989 and the Female students (as % of total students) of Secondary general education in 2004?
Your answer should be compact. 0.08. What is the difference between the Female students (as % of total students) in Tertiary education in 1989 and the Female students (as % of total students) in Secondary vocational education in 2004?
Offer a very short reply. 4.29. What is the difference between the Female students (as % of total students) of Secondary general education in 1989 and the Female students (as % of total students) of Secondary vocational education in 2004?
Offer a terse response. 3.77. What is the difference between the Female students (as % of total students) in Primary education in 1999 and the Female students (as % of total students) in Tertiary education in 2000?
Offer a terse response. -3.89. What is the difference between the Female students (as % of total students) of Primary education in 1999 and the Female students (as % of total students) of Secondary general education in 2000?
Provide a short and direct response. -3.71. What is the difference between the Female students (as % of total students) of Primary education in 1999 and the Female students (as % of total students) of Secondary vocational education in 2000?
Your answer should be compact. -7.25. What is the difference between the Female students (as % of total students) in Tertiary education in 1999 and the Female students (as % of total students) in Secondary general education in 2000?
Provide a succinct answer. 0.1. What is the difference between the Female students (as % of total students) in Tertiary education in 1999 and the Female students (as % of total students) in Secondary vocational education in 2000?
Your answer should be compact. -3.44. What is the difference between the Female students (as % of total students) of Secondary general education in 1999 and the Female students (as % of total students) of Secondary vocational education in 2000?
Offer a very short reply. -3.87. What is the difference between the Female students (as % of total students) in Primary education in 1999 and the Female students (as % of total students) in Tertiary education in 2001?
Keep it short and to the point. -4. What is the difference between the Female students (as % of total students) of Primary education in 1999 and the Female students (as % of total students) of Secondary general education in 2001?
Make the answer very short. -3.78. What is the difference between the Female students (as % of total students) of Primary education in 1999 and the Female students (as % of total students) of Secondary vocational education in 2001?
Provide a succinct answer. -8.64. What is the difference between the Female students (as % of total students) in Tertiary education in 1999 and the Female students (as % of total students) in Secondary general education in 2001?
Give a very brief answer. 0.03. What is the difference between the Female students (as % of total students) in Tertiary education in 1999 and the Female students (as % of total students) in Secondary vocational education in 2001?
Offer a terse response. -4.83. What is the difference between the Female students (as % of total students) in Secondary general education in 1999 and the Female students (as % of total students) in Secondary vocational education in 2001?
Provide a short and direct response. -5.26. What is the difference between the Female students (as % of total students) in Primary education in 1999 and the Female students (as % of total students) in Tertiary education in 2002?
Offer a terse response. -3.97. What is the difference between the Female students (as % of total students) of Primary education in 1999 and the Female students (as % of total students) of Secondary general education in 2002?
Your response must be concise. -3.62. What is the difference between the Female students (as % of total students) in Primary education in 1999 and the Female students (as % of total students) in Secondary vocational education in 2002?
Your response must be concise. -6.43. What is the difference between the Female students (as % of total students) of Tertiary education in 1999 and the Female students (as % of total students) of Secondary general education in 2002?
Make the answer very short. 0.19. What is the difference between the Female students (as % of total students) in Tertiary education in 1999 and the Female students (as % of total students) in Secondary vocational education in 2002?
Make the answer very short. -2.63. What is the difference between the Female students (as % of total students) of Secondary general education in 1999 and the Female students (as % of total students) of Secondary vocational education in 2002?
Your response must be concise. -3.06. What is the difference between the Female students (as % of total students) in Primary education in 1999 and the Female students (as % of total students) in Tertiary education in 2003?
Provide a short and direct response. -3.89. What is the difference between the Female students (as % of total students) of Primary education in 1999 and the Female students (as % of total students) of Secondary general education in 2003?
Your response must be concise. -3.93. What is the difference between the Female students (as % of total students) of Primary education in 1999 and the Female students (as % of total students) of Secondary vocational education in 2003?
Offer a very short reply. -25.31. What is the difference between the Female students (as % of total students) of Tertiary education in 1999 and the Female students (as % of total students) of Secondary general education in 2003?
Give a very brief answer. -0.12. What is the difference between the Female students (as % of total students) of Tertiary education in 1999 and the Female students (as % of total students) of Secondary vocational education in 2003?
Offer a terse response. -21.51. What is the difference between the Female students (as % of total students) of Secondary general education in 1999 and the Female students (as % of total students) of Secondary vocational education in 2003?
Provide a short and direct response. -21.94. What is the difference between the Female students (as % of total students) of Primary education in 1999 and the Female students (as % of total students) of Tertiary education in 2004?
Ensure brevity in your answer.  -3.77. What is the difference between the Female students (as % of total students) of Primary education in 1999 and the Female students (as % of total students) of Secondary general education in 2004?
Provide a succinct answer. -3.93. What is the difference between the Female students (as % of total students) in Primary education in 1999 and the Female students (as % of total students) in Secondary vocational education in 2004?
Give a very brief answer. 0.27. What is the difference between the Female students (as % of total students) of Tertiary education in 1999 and the Female students (as % of total students) of Secondary general education in 2004?
Provide a short and direct response. -0.13. What is the difference between the Female students (as % of total students) of Tertiary education in 1999 and the Female students (as % of total students) of Secondary vocational education in 2004?
Make the answer very short. 4.08. What is the difference between the Female students (as % of total students) in Secondary general education in 1999 and the Female students (as % of total students) in Secondary vocational education in 2004?
Make the answer very short. 3.65. What is the difference between the Female students (as % of total students) in Primary education in 2000 and the Female students (as % of total students) in Tertiary education in 2001?
Keep it short and to the point. -4.04. What is the difference between the Female students (as % of total students) of Primary education in 2000 and the Female students (as % of total students) of Secondary general education in 2001?
Offer a very short reply. -3.81. What is the difference between the Female students (as % of total students) in Primary education in 2000 and the Female students (as % of total students) in Secondary vocational education in 2001?
Offer a very short reply. -8.67. What is the difference between the Female students (as % of total students) in Tertiary education in 2000 and the Female students (as % of total students) in Secondary general education in 2001?
Keep it short and to the point. 0.11. What is the difference between the Female students (as % of total students) in Tertiary education in 2000 and the Female students (as % of total students) in Secondary vocational education in 2001?
Your response must be concise. -4.75. What is the difference between the Female students (as % of total students) of Secondary general education in 2000 and the Female students (as % of total students) of Secondary vocational education in 2001?
Give a very brief answer. -4.93. What is the difference between the Female students (as % of total students) of Primary education in 2000 and the Female students (as % of total students) of Tertiary education in 2002?
Provide a succinct answer. -4.01. What is the difference between the Female students (as % of total students) of Primary education in 2000 and the Female students (as % of total students) of Secondary general education in 2002?
Your response must be concise. -3.65. What is the difference between the Female students (as % of total students) in Primary education in 2000 and the Female students (as % of total students) in Secondary vocational education in 2002?
Your answer should be compact. -6.46. What is the difference between the Female students (as % of total students) in Tertiary education in 2000 and the Female students (as % of total students) in Secondary general education in 2002?
Make the answer very short. 0.27. What is the difference between the Female students (as % of total students) in Tertiary education in 2000 and the Female students (as % of total students) in Secondary vocational education in 2002?
Make the answer very short. -2.54. What is the difference between the Female students (as % of total students) of Secondary general education in 2000 and the Female students (as % of total students) of Secondary vocational education in 2002?
Offer a very short reply. -2.72. What is the difference between the Female students (as % of total students) of Primary education in 2000 and the Female students (as % of total students) of Tertiary education in 2003?
Ensure brevity in your answer.  -3.92. What is the difference between the Female students (as % of total students) of Primary education in 2000 and the Female students (as % of total students) of Secondary general education in 2003?
Provide a short and direct response. -3.96. What is the difference between the Female students (as % of total students) of Primary education in 2000 and the Female students (as % of total students) of Secondary vocational education in 2003?
Offer a terse response. -25.34. What is the difference between the Female students (as % of total students) of Tertiary education in 2000 and the Female students (as % of total students) of Secondary general education in 2003?
Your response must be concise. -0.03. What is the difference between the Female students (as % of total students) of Tertiary education in 2000 and the Female students (as % of total students) of Secondary vocational education in 2003?
Provide a short and direct response. -21.42. What is the difference between the Female students (as % of total students) of Secondary general education in 2000 and the Female students (as % of total students) of Secondary vocational education in 2003?
Keep it short and to the point. -21.6. What is the difference between the Female students (as % of total students) of Primary education in 2000 and the Female students (as % of total students) of Tertiary education in 2004?
Provide a succinct answer. -3.8. What is the difference between the Female students (as % of total students) of Primary education in 2000 and the Female students (as % of total students) of Secondary general education in 2004?
Your answer should be very brief. -3.96. What is the difference between the Female students (as % of total students) of Primary education in 2000 and the Female students (as % of total students) of Secondary vocational education in 2004?
Ensure brevity in your answer.  0.24. What is the difference between the Female students (as % of total students) of Tertiary education in 2000 and the Female students (as % of total students) of Secondary general education in 2004?
Give a very brief answer. -0.04. What is the difference between the Female students (as % of total students) in Tertiary education in 2000 and the Female students (as % of total students) in Secondary vocational education in 2004?
Offer a very short reply. 4.16. What is the difference between the Female students (as % of total students) of Secondary general education in 2000 and the Female students (as % of total students) of Secondary vocational education in 2004?
Your response must be concise. 3.98. What is the difference between the Female students (as % of total students) of Primary education in 2001 and the Female students (as % of total students) of Tertiary education in 2002?
Your answer should be compact. -3.95. What is the difference between the Female students (as % of total students) in Primary education in 2001 and the Female students (as % of total students) in Secondary general education in 2002?
Offer a terse response. -3.6. What is the difference between the Female students (as % of total students) in Primary education in 2001 and the Female students (as % of total students) in Secondary vocational education in 2002?
Offer a terse response. -6.41. What is the difference between the Female students (as % of total students) in Tertiary education in 2001 and the Female students (as % of total students) in Secondary general education in 2002?
Ensure brevity in your answer.  0.39. What is the difference between the Female students (as % of total students) in Tertiary education in 2001 and the Female students (as % of total students) in Secondary vocational education in 2002?
Provide a short and direct response. -2.43. What is the difference between the Female students (as % of total students) of Secondary general education in 2001 and the Female students (as % of total students) of Secondary vocational education in 2002?
Make the answer very short. -2.65. What is the difference between the Female students (as % of total students) of Primary education in 2001 and the Female students (as % of total students) of Tertiary education in 2003?
Offer a very short reply. -3.87. What is the difference between the Female students (as % of total students) in Primary education in 2001 and the Female students (as % of total students) in Secondary general education in 2003?
Give a very brief answer. -3.9. What is the difference between the Female students (as % of total students) in Primary education in 2001 and the Female students (as % of total students) in Secondary vocational education in 2003?
Make the answer very short. -25.29. What is the difference between the Female students (as % of total students) of Tertiary education in 2001 and the Female students (as % of total students) of Secondary general education in 2003?
Make the answer very short. 0.08. What is the difference between the Female students (as % of total students) in Tertiary education in 2001 and the Female students (as % of total students) in Secondary vocational education in 2003?
Your answer should be very brief. -21.31. What is the difference between the Female students (as % of total students) of Secondary general education in 2001 and the Female students (as % of total students) of Secondary vocational education in 2003?
Provide a succinct answer. -21.53. What is the difference between the Female students (as % of total students) in Primary education in 2001 and the Female students (as % of total students) in Tertiary education in 2004?
Provide a succinct answer. -3.75. What is the difference between the Female students (as % of total students) of Primary education in 2001 and the Female students (as % of total students) of Secondary general education in 2004?
Your answer should be very brief. -3.91. What is the difference between the Female students (as % of total students) of Primary education in 2001 and the Female students (as % of total students) of Secondary vocational education in 2004?
Your answer should be compact. 0.29. What is the difference between the Female students (as % of total students) of Tertiary education in 2001 and the Female students (as % of total students) of Secondary general education in 2004?
Offer a very short reply. 0.07. What is the difference between the Female students (as % of total students) in Tertiary education in 2001 and the Female students (as % of total students) in Secondary vocational education in 2004?
Make the answer very short. 4.27. What is the difference between the Female students (as % of total students) of Secondary general education in 2001 and the Female students (as % of total students) of Secondary vocational education in 2004?
Offer a very short reply. 4.05. What is the difference between the Female students (as % of total students) of Primary education in 2002 and the Female students (as % of total students) of Tertiary education in 2003?
Provide a succinct answer. -3.88. What is the difference between the Female students (as % of total students) in Primary education in 2002 and the Female students (as % of total students) in Secondary general education in 2003?
Your answer should be compact. -3.92. What is the difference between the Female students (as % of total students) of Primary education in 2002 and the Female students (as % of total students) of Secondary vocational education in 2003?
Ensure brevity in your answer.  -25.31. What is the difference between the Female students (as % of total students) in Tertiary education in 2002 and the Female students (as % of total students) in Secondary general education in 2003?
Your response must be concise. 0.05. What is the difference between the Female students (as % of total students) of Tertiary education in 2002 and the Female students (as % of total students) of Secondary vocational education in 2003?
Your response must be concise. -21.34. What is the difference between the Female students (as % of total students) in Secondary general education in 2002 and the Female students (as % of total students) in Secondary vocational education in 2003?
Keep it short and to the point. -21.7. What is the difference between the Female students (as % of total students) of Primary education in 2002 and the Female students (as % of total students) of Tertiary education in 2004?
Make the answer very short. -3.76. What is the difference between the Female students (as % of total students) of Primary education in 2002 and the Female students (as % of total students) of Secondary general education in 2004?
Ensure brevity in your answer.  -3.93. What is the difference between the Female students (as % of total students) in Primary education in 2002 and the Female students (as % of total students) in Secondary vocational education in 2004?
Offer a very short reply. 0.28. What is the difference between the Female students (as % of total students) in Tertiary education in 2002 and the Female students (as % of total students) in Secondary general education in 2004?
Ensure brevity in your answer.  0.04. What is the difference between the Female students (as % of total students) in Tertiary education in 2002 and the Female students (as % of total students) in Secondary vocational education in 2004?
Offer a terse response. 4.25. What is the difference between the Female students (as % of total students) in Secondary general education in 2002 and the Female students (as % of total students) in Secondary vocational education in 2004?
Your answer should be compact. 3.89. What is the difference between the Female students (as % of total students) in Primary education in 2003 and the Female students (as % of total students) in Tertiary education in 2004?
Ensure brevity in your answer.  -3.78. What is the difference between the Female students (as % of total students) of Primary education in 2003 and the Female students (as % of total students) of Secondary general education in 2004?
Your answer should be compact. -3.94. What is the difference between the Female students (as % of total students) of Primary education in 2003 and the Female students (as % of total students) of Secondary vocational education in 2004?
Keep it short and to the point. 0.26. What is the difference between the Female students (as % of total students) in Tertiary education in 2003 and the Female students (as % of total students) in Secondary general education in 2004?
Your answer should be very brief. -0.04. What is the difference between the Female students (as % of total students) of Tertiary education in 2003 and the Female students (as % of total students) of Secondary vocational education in 2004?
Give a very brief answer. 4.16. What is the difference between the Female students (as % of total students) in Secondary general education in 2003 and the Female students (as % of total students) in Secondary vocational education in 2004?
Your answer should be very brief. 4.2. What is the average Female students (as % of total students) in Primary education per year?
Keep it short and to the point. 48.2. What is the average Female students (as % of total students) in Tertiary education per year?
Keep it short and to the point. 51.67. What is the average Female students (as % of total students) of Secondary general education per year?
Ensure brevity in your answer.  51.46. What is the average Female students (as % of total students) of Secondary vocational education per year?
Give a very brief answer. 54.9. In the year 1974, what is the difference between the Female students (as % of total students) of Primary education and Female students (as % of total students) of Tertiary education?
Provide a succinct answer. -2.51. In the year 1974, what is the difference between the Female students (as % of total students) in Primary education and Female students (as % of total students) in Secondary general education?
Your response must be concise. -2.06. In the year 1974, what is the difference between the Female students (as % of total students) of Primary education and Female students (as % of total students) of Secondary vocational education?
Your answer should be compact. -5.52. In the year 1974, what is the difference between the Female students (as % of total students) of Tertiary education and Female students (as % of total students) of Secondary general education?
Give a very brief answer. 0.46. In the year 1974, what is the difference between the Female students (as % of total students) in Tertiary education and Female students (as % of total students) in Secondary vocational education?
Offer a very short reply. -3.01. In the year 1974, what is the difference between the Female students (as % of total students) in Secondary general education and Female students (as % of total students) in Secondary vocational education?
Provide a short and direct response. -3.47. In the year 1979, what is the difference between the Female students (as % of total students) of Primary education and Female students (as % of total students) of Tertiary education?
Offer a very short reply. -2.76. In the year 1979, what is the difference between the Female students (as % of total students) of Primary education and Female students (as % of total students) of Secondary general education?
Your answer should be very brief. -2.89. In the year 1979, what is the difference between the Female students (as % of total students) in Primary education and Female students (as % of total students) in Secondary vocational education?
Offer a very short reply. 4.24. In the year 1979, what is the difference between the Female students (as % of total students) of Tertiary education and Female students (as % of total students) of Secondary general education?
Ensure brevity in your answer.  -0.14. In the year 1979, what is the difference between the Female students (as % of total students) in Tertiary education and Female students (as % of total students) in Secondary vocational education?
Your answer should be compact. 6.99. In the year 1979, what is the difference between the Female students (as % of total students) in Secondary general education and Female students (as % of total students) in Secondary vocational education?
Your response must be concise. 7.13. In the year 1989, what is the difference between the Female students (as % of total students) of Primary education and Female students (as % of total students) of Tertiary education?
Offer a terse response. -2.52. In the year 1989, what is the difference between the Female students (as % of total students) of Primary education and Female students (as % of total students) of Secondary vocational education?
Your answer should be very brief. -5.13. In the year 1989, what is the difference between the Female students (as % of total students) of Tertiary education and Female students (as % of total students) of Secondary general education?
Offer a terse response. 0.52. In the year 1989, what is the difference between the Female students (as % of total students) in Tertiary education and Female students (as % of total students) in Secondary vocational education?
Provide a succinct answer. -2.61. In the year 1989, what is the difference between the Female students (as % of total students) of Secondary general education and Female students (as % of total students) of Secondary vocational education?
Offer a very short reply. -3.13. In the year 1999, what is the difference between the Female students (as % of total students) in Primary education and Female students (as % of total students) in Tertiary education?
Make the answer very short. -3.81. In the year 1999, what is the difference between the Female students (as % of total students) in Primary education and Female students (as % of total students) in Secondary general education?
Provide a short and direct response. -3.38. In the year 1999, what is the difference between the Female students (as % of total students) of Primary education and Female students (as % of total students) of Secondary vocational education?
Provide a short and direct response. -6.44. In the year 1999, what is the difference between the Female students (as % of total students) in Tertiary education and Female students (as % of total students) in Secondary general education?
Keep it short and to the point. 0.43. In the year 1999, what is the difference between the Female students (as % of total students) of Tertiary education and Female students (as % of total students) of Secondary vocational education?
Provide a succinct answer. -2.63. In the year 1999, what is the difference between the Female students (as % of total students) in Secondary general education and Female students (as % of total students) in Secondary vocational education?
Ensure brevity in your answer.  -3.07. In the year 2000, what is the difference between the Female students (as % of total students) in Primary education and Female students (as % of total students) in Tertiary education?
Ensure brevity in your answer.  -3.92. In the year 2000, what is the difference between the Female students (as % of total students) of Primary education and Female students (as % of total students) of Secondary general education?
Offer a very short reply. -3.74. In the year 2000, what is the difference between the Female students (as % of total students) in Primary education and Female students (as % of total students) in Secondary vocational education?
Offer a terse response. -7.28. In the year 2000, what is the difference between the Female students (as % of total students) of Tertiary education and Female students (as % of total students) of Secondary general education?
Your response must be concise. 0.18. In the year 2000, what is the difference between the Female students (as % of total students) of Tertiary education and Female students (as % of total students) of Secondary vocational education?
Provide a short and direct response. -3.36. In the year 2000, what is the difference between the Female students (as % of total students) in Secondary general education and Female students (as % of total students) in Secondary vocational education?
Keep it short and to the point. -3.54. In the year 2001, what is the difference between the Female students (as % of total students) in Primary education and Female students (as % of total students) in Tertiary education?
Make the answer very short. -3.98. In the year 2001, what is the difference between the Female students (as % of total students) in Primary education and Female students (as % of total students) in Secondary general education?
Your answer should be compact. -3.76. In the year 2001, what is the difference between the Female students (as % of total students) of Primary education and Female students (as % of total students) of Secondary vocational education?
Your answer should be compact. -8.61. In the year 2001, what is the difference between the Female students (as % of total students) of Tertiary education and Female students (as % of total students) of Secondary general education?
Your answer should be compact. 0.22. In the year 2001, what is the difference between the Female students (as % of total students) of Tertiary education and Female students (as % of total students) of Secondary vocational education?
Make the answer very short. -4.63. In the year 2001, what is the difference between the Female students (as % of total students) of Secondary general education and Female students (as % of total students) of Secondary vocational education?
Provide a succinct answer. -4.86. In the year 2002, what is the difference between the Female students (as % of total students) in Primary education and Female students (as % of total students) in Tertiary education?
Offer a very short reply. -3.97. In the year 2002, what is the difference between the Female students (as % of total students) of Primary education and Female students (as % of total students) of Secondary general education?
Offer a very short reply. -3.61. In the year 2002, what is the difference between the Female students (as % of total students) in Primary education and Female students (as % of total students) in Secondary vocational education?
Your response must be concise. -6.43. In the year 2002, what is the difference between the Female students (as % of total students) in Tertiary education and Female students (as % of total students) in Secondary general education?
Keep it short and to the point. 0.36. In the year 2002, what is the difference between the Female students (as % of total students) in Tertiary education and Female students (as % of total students) in Secondary vocational education?
Keep it short and to the point. -2.46. In the year 2002, what is the difference between the Female students (as % of total students) in Secondary general education and Female students (as % of total students) in Secondary vocational education?
Keep it short and to the point. -2.81. In the year 2003, what is the difference between the Female students (as % of total students) in Primary education and Female students (as % of total students) in Tertiary education?
Your response must be concise. -3.9. In the year 2003, what is the difference between the Female students (as % of total students) in Primary education and Female students (as % of total students) in Secondary general education?
Provide a short and direct response. -3.94. In the year 2003, what is the difference between the Female students (as % of total students) in Primary education and Female students (as % of total students) in Secondary vocational education?
Offer a terse response. -25.32. In the year 2003, what is the difference between the Female students (as % of total students) of Tertiary education and Female students (as % of total students) of Secondary general education?
Provide a short and direct response. -0.04. In the year 2003, what is the difference between the Female students (as % of total students) in Tertiary education and Female students (as % of total students) in Secondary vocational education?
Offer a terse response. -21.42. In the year 2003, what is the difference between the Female students (as % of total students) in Secondary general education and Female students (as % of total students) in Secondary vocational education?
Give a very brief answer. -21.39. In the year 2004, what is the difference between the Female students (as % of total students) in Primary education and Female students (as % of total students) in Tertiary education?
Make the answer very short. -3.79. In the year 2004, what is the difference between the Female students (as % of total students) of Primary education and Female students (as % of total students) of Secondary general education?
Your answer should be very brief. -3.96. In the year 2004, what is the difference between the Female students (as % of total students) of Primary education and Female students (as % of total students) of Secondary vocational education?
Make the answer very short. 0.25. In the year 2004, what is the difference between the Female students (as % of total students) of Tertiary education and Female students (as % of total students) of Secondary general education?
Provide a succinct answer. -0.17. In the year 2004, what is the difference between the Female students (as % of total students) of Tertiary education and Female students (as % of total students) of Secondary vocational education?
Make the answer very short. 4.04. In the year 2004, what is the difference between the Female students (as % of total students) in Secondary general education and Female students (as % of total students) in Secondary vocational education?
Provide a succinct answer. 4.2. What is the ratio of the Female students (as % of total students) in Primary education in 1974 to that in 1979?
Keep it short and to the point. 1.01. What is the ratio of the Female students (as % of total students) in Tertiary education in 1974 to that in 1979?
Provide a short and direct response. 1.01. What is the ratio of the Female students (as % of total students) in Secondary vocational education in 1974 to that in 1979?
Give a very brief answer. 1.23. What is the ratio of the Female students (as % of total students) of Primary education in 1974 to that in 1989?
Your response must be concise. 1. What is the ratio of the Female students (as % of total students) in Tertiary education in 1974 to that in 1989?
Ensure brevity in your answer.  1. What is the ratio of the Female students (as % of total students) in Secondary general education in 1974 to that in 1989?
Provide a short and direct response. 1.01. What is the ratio of the Female students (as % of total students) of Secondary vocational education in 1974 to that in 1989?
Offer a terse response. 1.01. What is the ratio of the Female students (as % of total students) of Primary education in 1974 to that in 1999?
Your answer should be very brief. 1.04. What is the ratio of the Female students (as % of total students) of Tertiary education in 1974 to that in 1999?
Ensure brevity in your answer.  1.01. What is the ratio of the Female students (as % of total students) in Secondary general education in 1974 to that in 1999?
Your answer should be compact. 1.01. What is the ratio of the Female students (as % of total students) in Secondary vocational education in 1974 to that in 1999?
Provide a short and direct response. 1.01. What is the ratio of the Female students (as % of total students) in Primary education in 1974 to that in 2000?
Make the answer very short. 1.04. What is the ratio of the Female students (as % of total students) of Tertiary education in 1974 to that in 2000?
Offer a terse response. 1.01. What is the ratio of the Female students (as % of total students) of Secondary general education in 1974 to that in 2000?
Provide a short and direct response. 1. What is the ratio of the Female students (as % of total students) in Secondary vocational education in 1974 to that in 2000?
Offer a terse response. 1. What is the ratio of the Female students (as % of total students) of Primary education in 1974 to that in 2001?
Offer a very short reply. 1.04. What is the ratio of the Female students (as % of total students) of Secondary vocational education in 1974 to that in 2001?
Provide a short and direct response. 0.98. What is the ratio of the Female students (as % of total students) of Primary education in 1974 to that in 2002?
Offer a very short reply. 1.04. What is the ratio of the Female students (as % of total students) of Secondary vocational education in 1974 to that in 2002?
Offer a very short reply. 1.01. What is the ratio of the Female students (as % of total students) in Primary education in 1974 to that in 2003?
Provide a succinct answer. 1.04. What is the ratio of the Female students (as % of total students) of Tertiary education in 1974 to that in 2003?
Your answer should be very brief. 1.01. What is the ratio of the Female students (as % of total students) of Secondary general education in 1974 to that in 2003?
Give a very brief answer. 1. What is the ratio of the Female students (as % of total students) in Secondary vocational education in 1974 to that in 2003?
Keep it short and to the point. 0.75. What is the ratio of the Female students (as % of total students) in Primary education in 1974 to that in 2004?
Make the answer very short. 1.04. What is the ratio of the Female students (as % of total students) of Tertiary education in 1974 to that in 2004?
Your answer should be very brief. 1.01. What is the ratio of the Female students (as % of total students) in Secondary vocational education in 1974 to that in 2004?
Provide a short and direct response. 1.16. What is the ratio of the Female students (as % of total students) in Secondary general education in 1979 to that in 1989?
Make the answer very short. 1.01. What is the ratio of the Female students (as % of total students) in Secondary vocational education in 1979 to that in 1989?
Your answer should be very brief. 0.82. What is the ratio of the Female students (as % of total students) in Primary education in 1979 to that in 1999?
Give a very brief answer. 1.02. What is the ratio of the Female students (as % of total students) in Tertiary education in 1979 to that in 1999?
Keep it short and to the point. 1. What is the ratio of the Female students (as % of total students) of Secondary general education in 1979 to that in 1999?
Ensure brevity in your answer.  1.01. What is the ratio of the Female students (as % of total students) in Secondary vocational education in 1979 to that in 1999?
Keep it short and to the point. 0.82. What is the ratio of the Female students (as % of total students) in Primary education in 1979 to that in 2000?
Offer a very short reply. 1.02. What is the ratio of the Female students (as % of total students) in Tertiary education in 1979 to that in 2000?
Ensure brevity in your answer.  1. What is the ratio of the Female students (as % of total students) in Secondary vocational education in 1979 to that in 2000?
Provide a short and direct response. 0.81. What is the ratio of the Female students (as % of total students) of Primary education in 1979 to that in 2001?
Give a very brief answer. 1.02. What is the ratio of the Female students (as % of total students) of Tertiary education in 1979 to that in 2001?
Offer a terse response. 1. What is the ratio of the Female students (as % of total students) in Secondary vocational education in 1979 to that in 2001?
Offer a very short reply. 0.79. What is the ratio of the Female students (as % of total students) of Primary education in 1979 to that in 2002?
Your response must be concise. 1.02. What is the ratio of the Female students (as % of total students) of Tertiary education in 1979 to that in 2002?
Offer a terse response. 1. What is the ratio of the Female students (as % of total students) of Secondary general education in 1979 to that in 2002?
Provide a succinct answer. 1.01. What is the ratio of the Female students (as % of total students) in Secondary vocational education in 1979 to that in 2002?
Offer a very short reply. 0.82. What is the ratio of the Female students (as % of total students) in Primary education in 1979 to that in 2003?
Ensure brevity in your answer.  1.02. What is the ratio of the Female students (as % of total students) in Secondary vocational education in 1979 to that in 2003?
Offer a very short reply. 0.61. What is the ratio of the Female students (as % of total students) of Primary education in 1979 to that in 2004?
Your response must be concise. 1.02. What is the ratio of the Female students (as % of total students) of Secondary vocational education in 1979 to that in 2004?
Your answer should be very brief. 0.94. What is the ratio of the Female students (as % of total students) in Primary education in 1989 to that in 1999?
Provide a short and direct response. 1.03. What is the ratio of the Female students (as % of total students) of Primary education in 1989 to that in 2000?
Your answer should be very brief. 1.03. What is the ratio of the Female students (as % of total students) in Tertiary education in 1989 to that in 2000?
Ensure brevity in your answer.  1. What is the ratio of the Female students (as % of total students) of Secondary vocational education in 1989 to that in 2000?
Ensure brevity in your answer.  0.99. What is the ratio of the Female students (as % of total students) in Primary education in 1989 to that in 2001?
Offer a terse response. 1.03. What is the ratio of the Female students (as % of total students) in Secondary general education in 1989 to that in 2001?
Make the answer very short. 0.99. What is the ratio of the Female students (as % of total students) in Primary education in 1989 to that in 2002?
Provide a short and direct response. 1.03. What is the ratio of the Female students (as % of total students) of Secondary vocational education in 1989 to that in 2002?
Make the answer very short. 1. What is the ratio of the Female students (as % of total students) in Primary education in 1989 to that in 2003?
Your answer should be very brief. 1.03. What is the ratio of the Female students (as % of total students) of Secondary vocational education in 1989 to that in 2003?
Offer a very short reply. 0.74. What is the ratio of the Female students (as % of total students) in Primary education in 1989 to that in 2004?
Offer a very short reply. 1.03. What is the ratio of the Female students (as % of total students) of Secondary general education in 1989 to that in 2004?
Keep it short and to the point. 0.99. What is the ratio of the Female students (as % of total students) of Secondary vocational education in 1989 to that in 2004?
Ensure brevity in your answer.  1.15. What is the ratio of the Female students (as % of total students) in Secondary general education in 1999 to that in 2000?
Give a very brief answer. 0.99. What is the ratio of the Female students (as % of total students) in Secondary vocational education in 1999 to that in 2000?
Your response must be concise. 0.99. What is the ratio of the Female students (as % of total students) in Primary education in 1999 to that in 2001?
Provide a succinct answer. 1. What is the ratio of the Female students (as % of total students) of Tertiary education in 1999 to that in 2001?
Provide a short and direct response. 1. What is the ratio of the Female students (as % of total students) in Secondary vocational education in 1999 to that in 2001?
Make the answer very short. 0.96. What is the ratio of the Female students (as % of total students) in Tertiary education in 1999 to that in 2002?
Make the answer very short. 1. What is the ratio of the Female students (as % of total students) of Secondary general education in 1999 to that in 2002?
Give a very brief answer. 1. What is the ratio of the Female students (as % of total students) of Primary education in 1999 to that in 2003?
Keep it short and to the point. 1. What is the ratio of the Female students (as % of total students) in Secondary general education in 1999 to that in 2003?
Give a very brief answer. 0.99. What is the ratio of the Female students (as % of total students) of Secondary vocational education in 1999 to that in 2003?
Give a very brief answer. 0.74. What is the ratio of the Female students (as % of total students) of Primary education in 1999 to that in 2004?
Provide a short and direct response. 1. What is the ratio of the Female students (as % of total students) in Secondary general education in 1999 to that in 2004?
Make the answer very short. 0.99. What is the ratio of the Female students (as % of total students) in Secondary vocational education in 1999 to that in 2004?
Offer a very short reply. 1.14. What is the ratio of the Female students (as % of total students) in Secondary general education in 2000 to that in 2001?
Provide a short and direct response. 1. What is the ratio of the Female students (as % of total students) in Secondary vocational education in 2000 to that in 2001?
Offer a very short reply. 0.98. What is the ratio of the Female students (as % of total students) of Primary education in 2000 to that in 2002?
Make the answer very short. 1. What is the ratio of the Female students (as % of total students) in Secondary vocational education in 2000 to that in 2002?
Give a very brief answer. 1.02. What is the ratio of the Female students (as % of total students) of Primary education in 2000 to that in 2003?
Give a very brief answer. 1. What is the ratio of the Female students (as % of total students) of Secondary general education in 2000 to that in 2003?
Provide a succinct answer. 1. What is the ratio of the Female students (as % of total students) of Secondary vocational education in 2000 to that in 2003?
Your response must be concise. 0.75. What is the ratio of the Female students (as % of total students) of Tertiary education in 2000 to that in 2004?
Give a very brief answer. 1. What is the ratio of the Female students (as % of total students) in Secondary general education in 2000 to that in 2004?
Make the answer very short. 1. What is the ratio of the Female students (as % of total students) in Secondary vocational education in 2000 to that in 2004?
Your answer should be compact. 1.16. What is the ratio of the Female students (as % of total students) of Primary education in 2001 to that in 2002?
Provide a short and direct response. 1. What is the ratio of the Female students (as % of total students) of Tertiary education in 2001 to that in 2002?
Your answer should be very brief. 1. What is the ratio of the Female students (as % of total students) of Secondary vocational education in 2001 to that in 2002?
Provide a succinct answer. 1.04. What is the ratio of the Female students (as % of total students) of Secondary vocational education in 2001 to that in 2003?
Your response must be concise. 0.77. What is the ratio of the Female students (as % of total students) in Primary education in 2001 to that in 2004?
Your answer should be very brief. 1. What is the ratio of the Female students (as % of total students) in Secondary vocational education in 2001 to that in 2004?
Your answer should be very brief. 1.19. What is the ratio of the Female students (as % of total students) of Primary education in 2002 to that in 2003?
Ensure brevity in your answer.  1. What is the ratio of the Female students (as % of total students) in Secondary vocational education in 2002 to that in 2003?
Give a very brief answer. 0.74. What is the ratio of the Female students (as % of total students) in Tertiary education in 2002 to that in 2004?
Give a very brief answer. 1. What is the ratio of the Female students (as % of total students) in Secondary general education in 2002 to that in 2004?
Give a very brief answer. 0.99. What is the ratio of the Female students (as % of total students) in Secondary vocational education in 2002 to that in 2004?
Your answer should be compact. 1.14. What is the ratio of the Female students (as % of total students) of Primary education in 2003 to that in 2004?
Provide a succinct answer. 1. What is the ratio of the Female students (as % of total students) in Tertiary education in 2003 to that in 2004?
Offer a very short reply. 1. What is the ratio of the Female students (as % of total students) in Secondary general education in 2003 to that in 2004?
Offer a very short reply. 1. What is the ratio of the Female students (as % of total students) of Secondary vocational education in 2003 to that in 2004?
Ensure brevity in your answer.  1.54. What is the difference between the highest and the second highest Female students (as % of total students) of Primary education?
Provide a succinct answer. 0.22. What is the difference between the highest and the second highest Female students (as % of total students) of Tertiary education?
Provide a succinct answer. 0.22. What is the difference between the highest and the second highest Female students (as % of total students) of Secondary general education?
Ensure brevity in your answer.  0.03. What is the difference between the highest and the second highest Female students (as % of total students) in Secondary vocational education?
Your answer should be very brief. 16.68. What is the difference between the highest and the lowest Female students (as % of total students) of Primary education?
Your response must be concise. 1.75. What is the difference between the highest and the lowest Female students (as % of total students) in Tertiary education?
Provide a short and direct response. 0.47. What is the difference between the highest and the lowest Female students (as % of total students) of Secondary general education?
Keep it short and to the point. 0.59. What is the difference between the highest and the lowest Female students (as % of total students) in Secondary vocational education?
Provide a succinct answer. 28.48. 